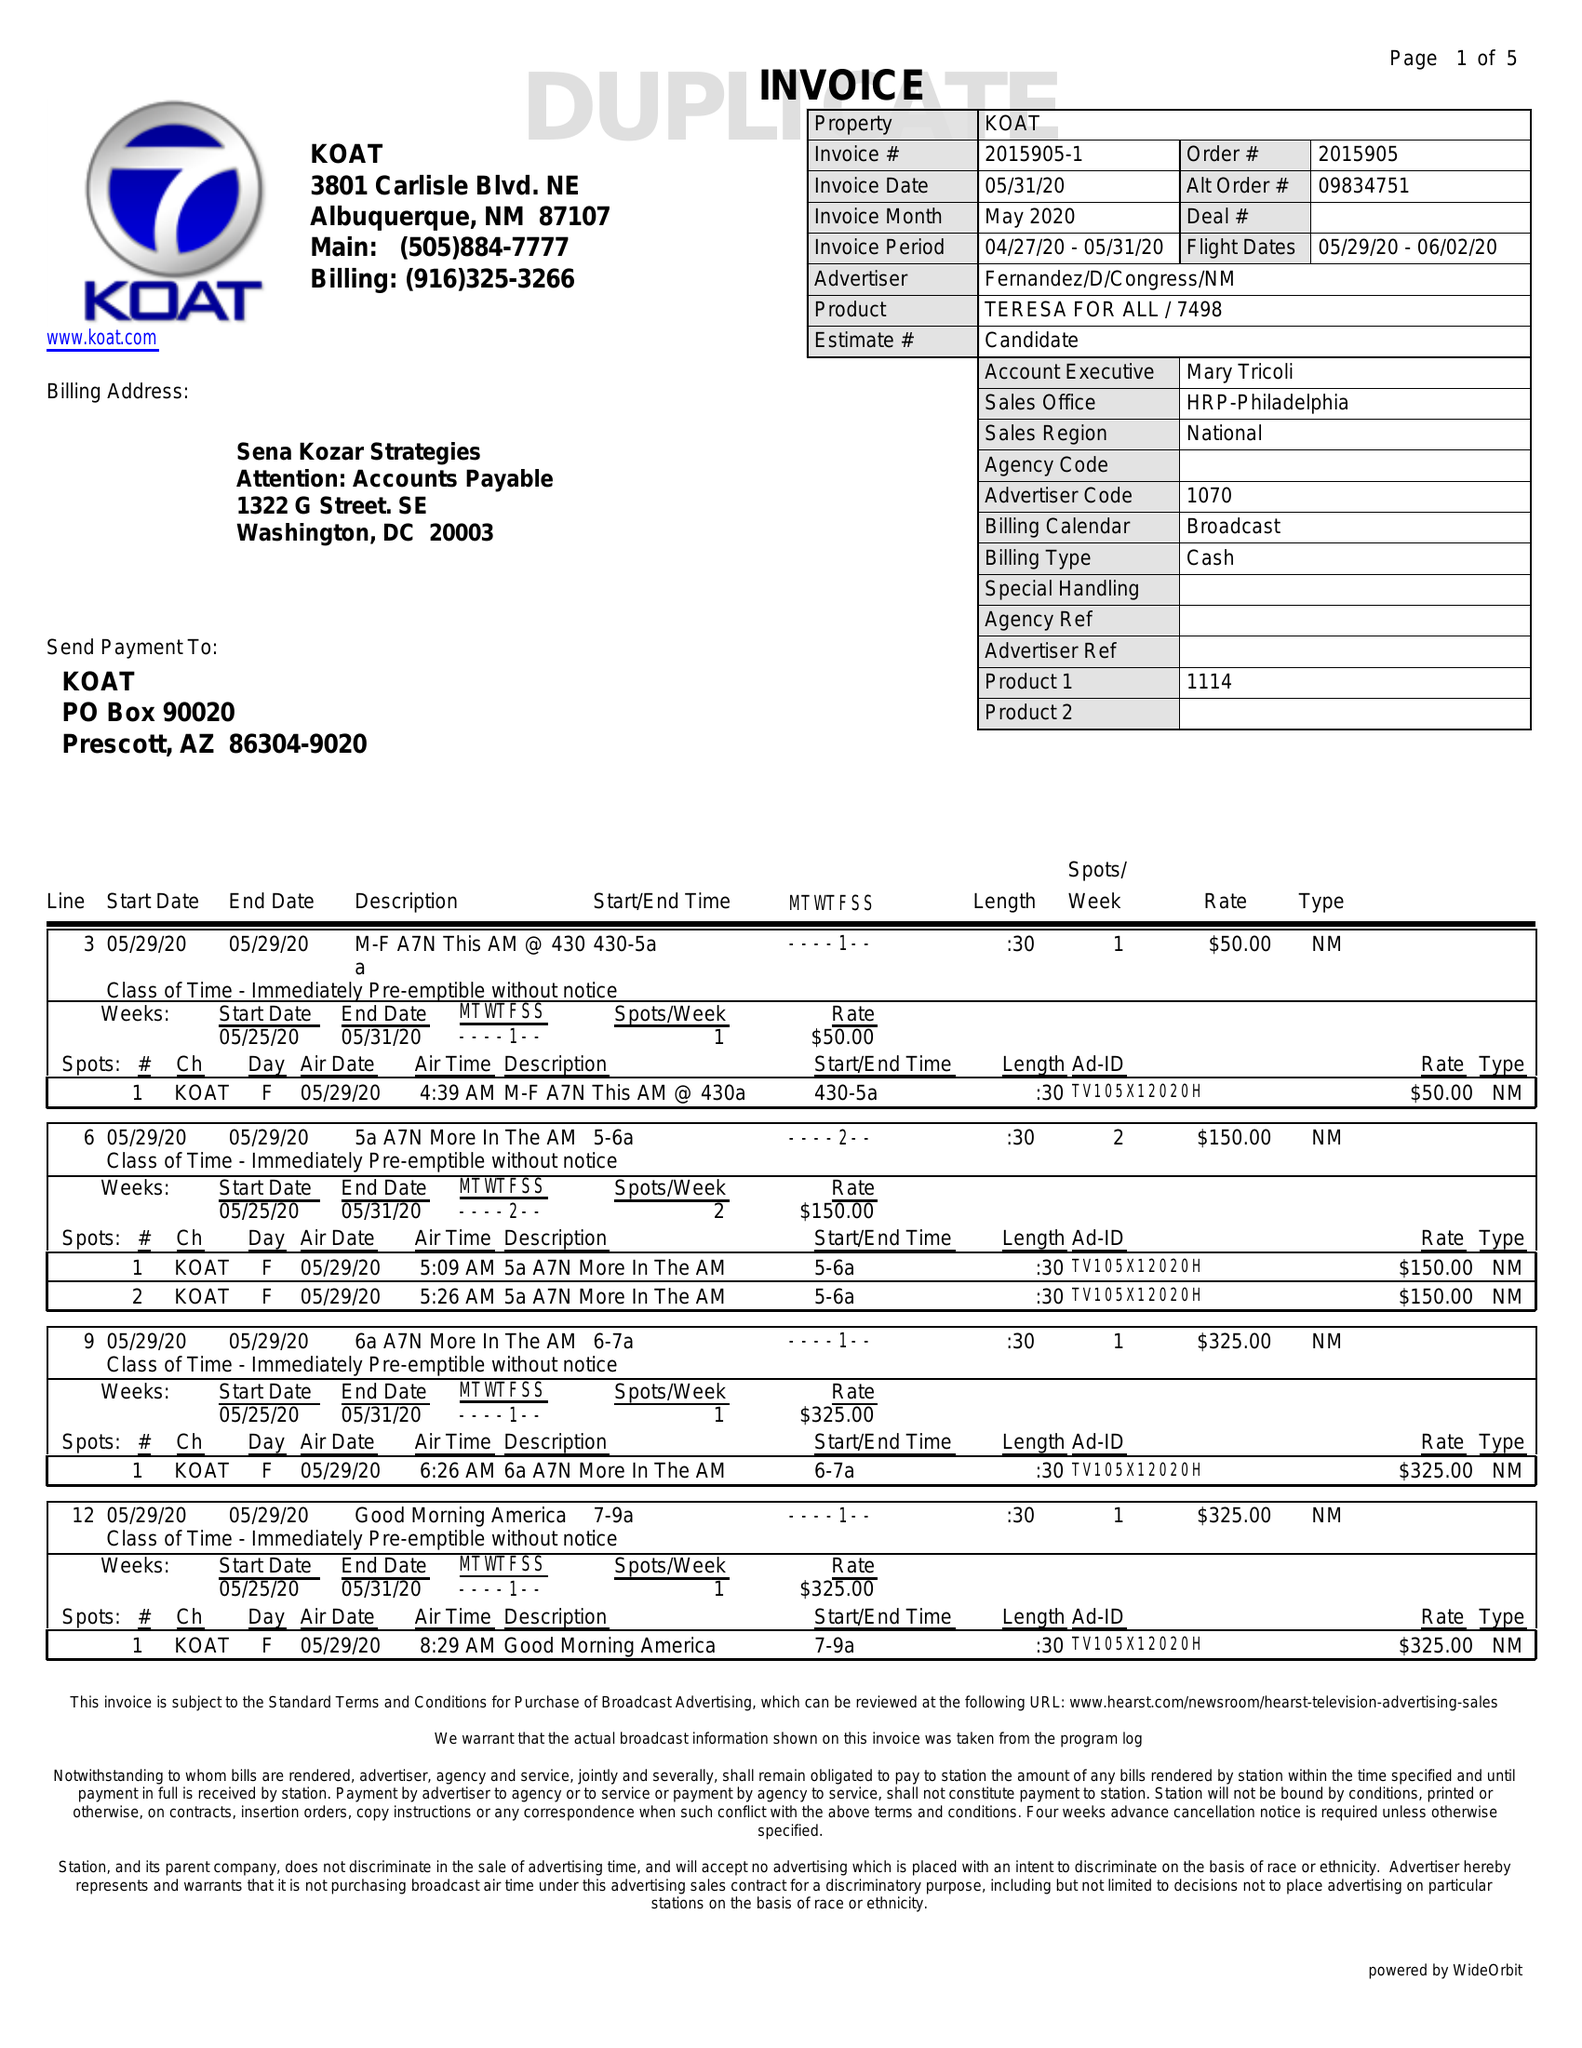What is the value for the flight_to?
Answer the question using a single word or phrase. 06/02/20 